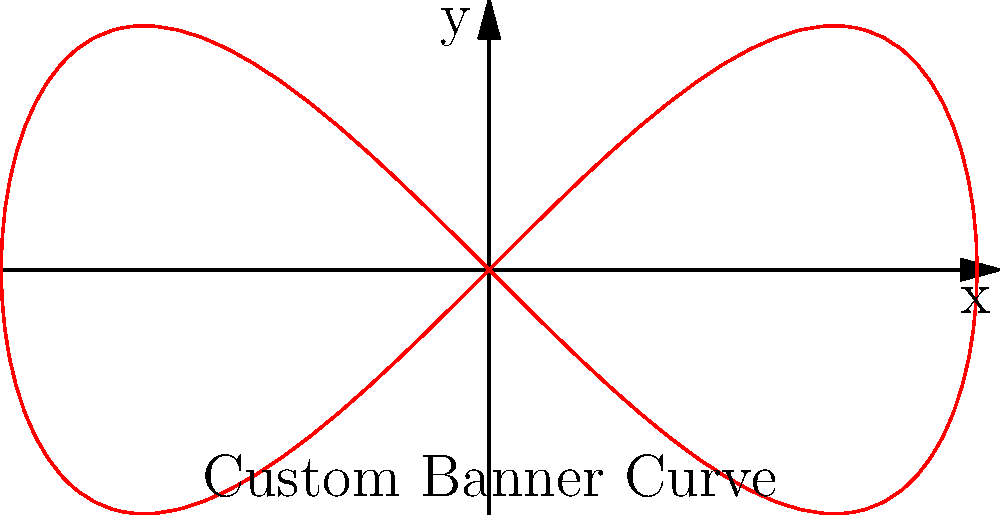You are designing a custom banner with a unique curved edge. The curve is represented by the parametric equations $x = 2\cos(t)$ and $y = \sin(2t)$, where $0 \leq t \leq 2\pi$. Calculate the total arc length of this curve to determine the amount of material needed for the banner's edge. To find the arc length of a parametric curve, we use the formula:

$$ L = \int_{a}^{b} \sqrt{\left(\frac{dx}{dt}\right)^2 + \left(\frac{dy}{dt}\right)^2} dt $$

Step 1: Find $\frac{dx}{dt}$ and $\frac{dy}{dt}$
$\frac{dx}{dt} = -2\sin(t)$
$\frac{dy}{dt} = 2\cos(2t)$

Step 2: Substitute into the arc length formula
$$ L = \int_{0}^{2\pi} \sqrt{(-2\sin(t))^2 + (2\cos(2t))^2} dt $$

Step 3: Simplify under the square root
$$ L = \int_{0}^{2\pi} \sqrt{4\sin^2(t) + 4\cos^2(2t)} dt $$

Step 4: Use the identity $\cos^2(2t) = \frac{1+\cos(4t)}{2}$
$$ L = \int_{0}^{2\pi} \sqrt{4\sin^2(t) + 2 + 2\cos(4t)} dt $$

Step 5: Use the identity $\sin^2(t) = \frac{1-\cos(2t)}{2}$
$$ L = \int_{0}^{2\pi} \sqrt{2 - 2\cos(2t) + 2 + 2\cos(4t)} dt $$
$$ L = \int_{0}^{2\pi} \sqrt{4 - 2\cos(2t) + 2\cos(4t)} dt $$

Step 6: This integral cannot be solved analytically, so we need to use numerical methods to approximate the result. Using a computer algebra system or numerical integration tool, we find:

$$ L \approx 9.6884 $$
Answer: $9.6884$ units 